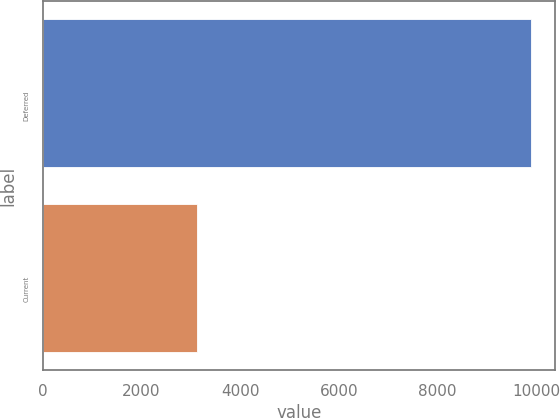<chart> <loc_0><loc_0><loc_500><loc_500><bar_chart><fcel>Deferred<fcel>Current<nl><fcel>9885<fcel>3134<nl></chart> 